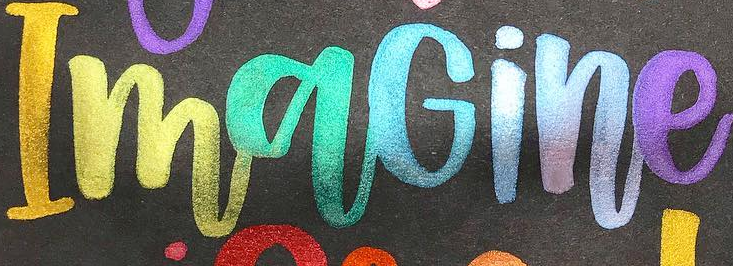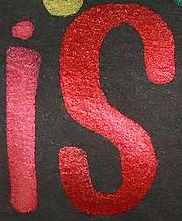Read the text from these images in sequence, separated by a semicolon. ImaGine; is 